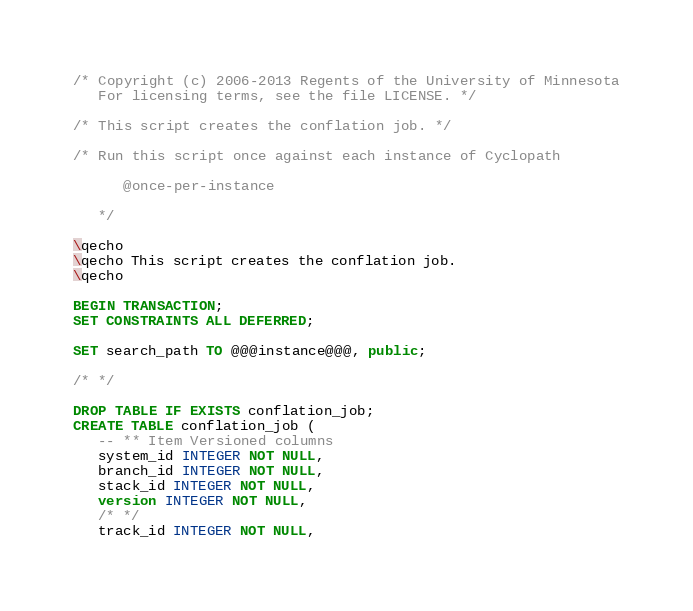<code> <loc_0><loc_0><loc_500><loc_500><_SQL_>/* Copyright (c) 2006-2013 Regents of the University of Minnesota
   For licensing terms, see the file LICENSE. */

/* This script creates the conflation job. */

/* Run this script once against each instance of Cyclopath

      @once-per-instance

   */

\qecho
\qecho This script creates the conflation job.
\qecho

BEGIN TRANSACTION;
SET CONSTRAINTS ALL DEFERRED;

SET search_path TO @@@instance@@@, public;

/* */

DROP TABLE IF EXISTS conflation_job;
CREATE TABLE conflation_job (
   -- ** Item Versioned columns
   system_id INTEGER NOT NULL,
   branch_id INTEGER NOT NULL,
   stack_id INTEGER NOT NULL,
   version INTEGER NOT NULL,
   /* */
   track_id INTEGER NOT NULL,</code> 